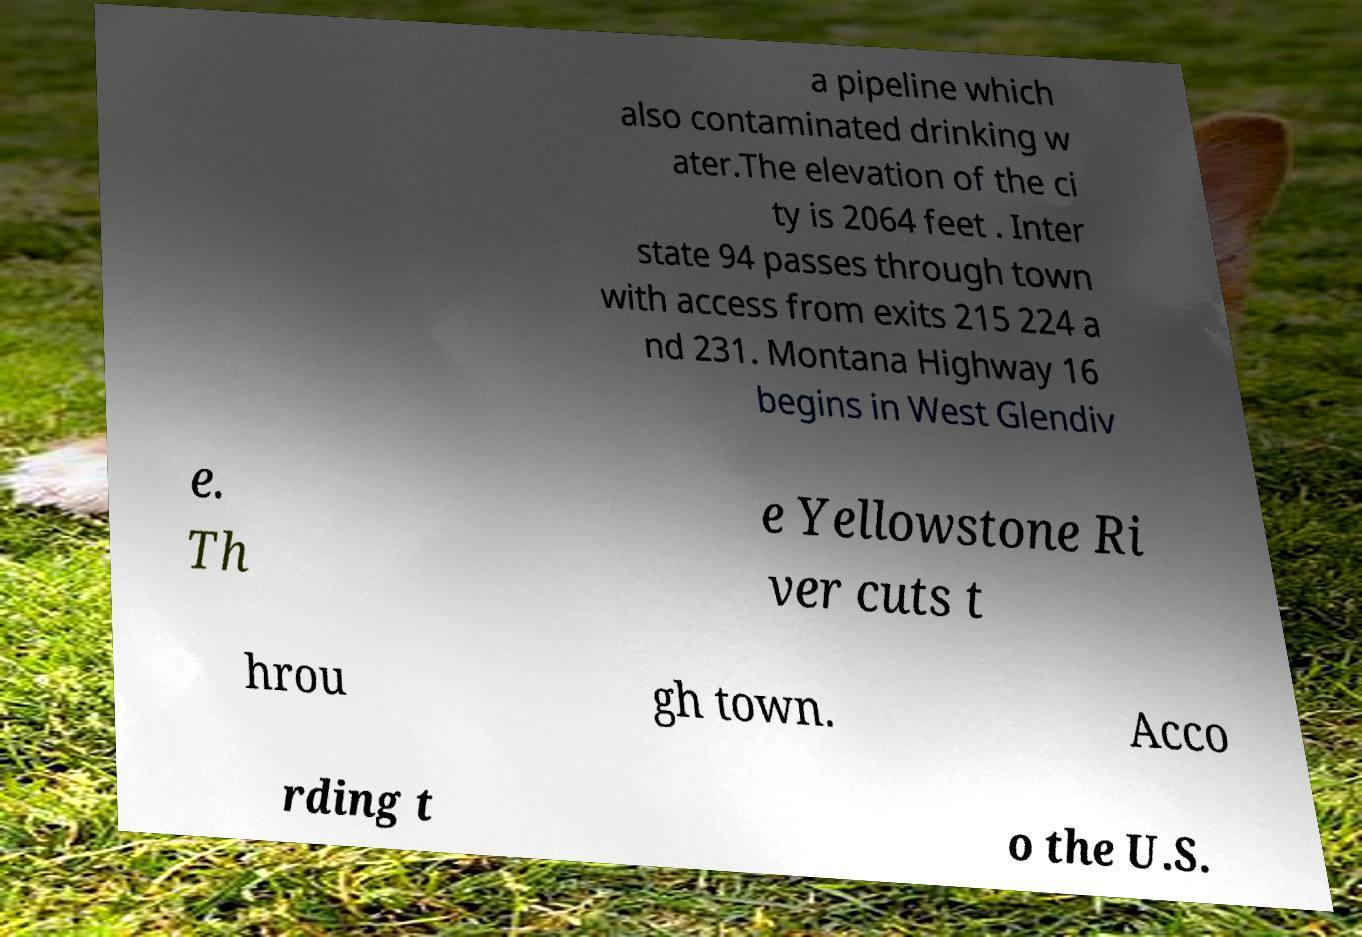Could you assist in decoding the text presented in this image and type it out clearly? a pipeline which also contaminated drinking w ater.The elevation of the ci ty is 2064 feet . Inter state 94 passes through town with access from exits 215 224 a nd 231. Montana Highway 16 begins in West Glendiv e. Th e Yellowstone Ri ver cuts t hrou gh town. Acco rding t o the U.S. 